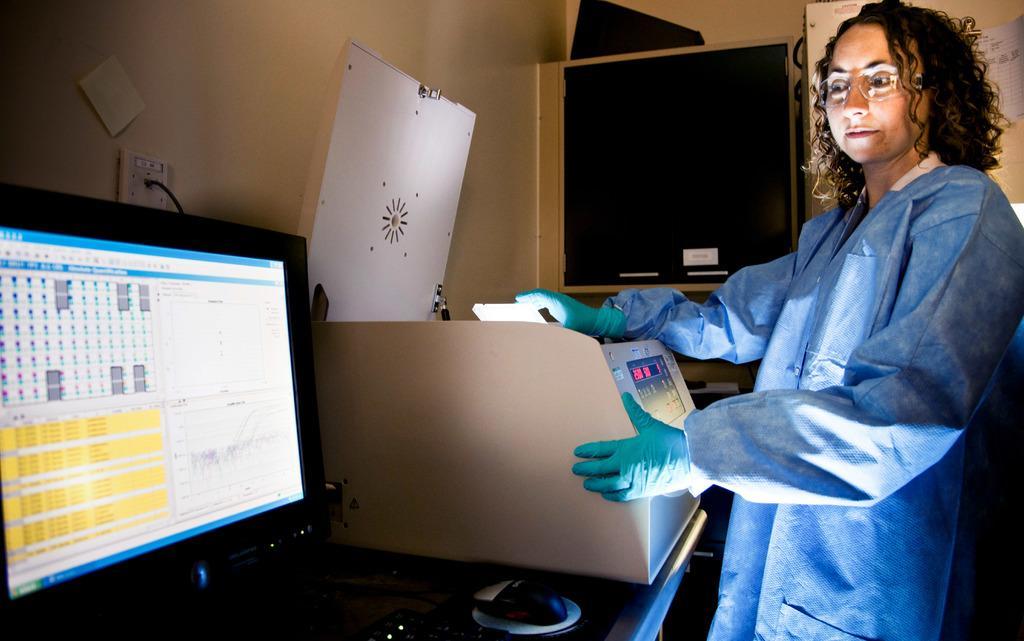In one or two sentences, can you explain what this image depicts? In this picture I can observe a woman standing on the right side. She is wearing blue color coat and wearing gloves to her hands. On the left side I can observe a computer placed on the desk. In the middle of the picture there is an equipment. In the background I can observe a wall. 